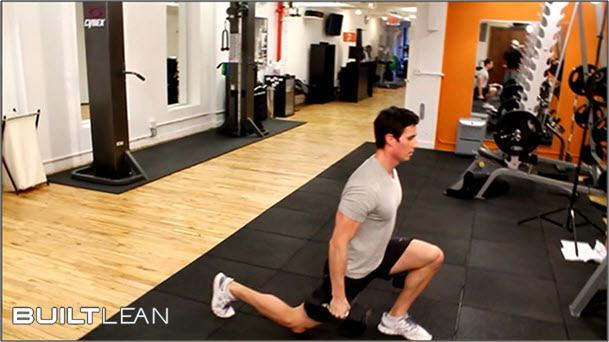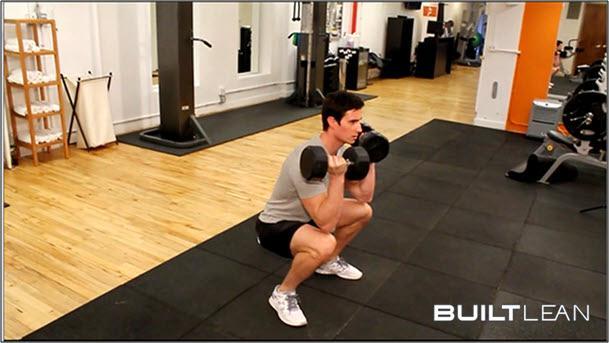The first image is the image on the left, the second image is the image on the right. For the images shown, is this caption "One of the guys does some leg-work near a red wall." true? Answer yes or no. No. The first image is the image on the left, the second image is the image on the right. Given the left and right images, does the statement "There is a man wearing a black shirt and black shorts with a dumbbell in each hand." hold true? Answer yes or no. No. 